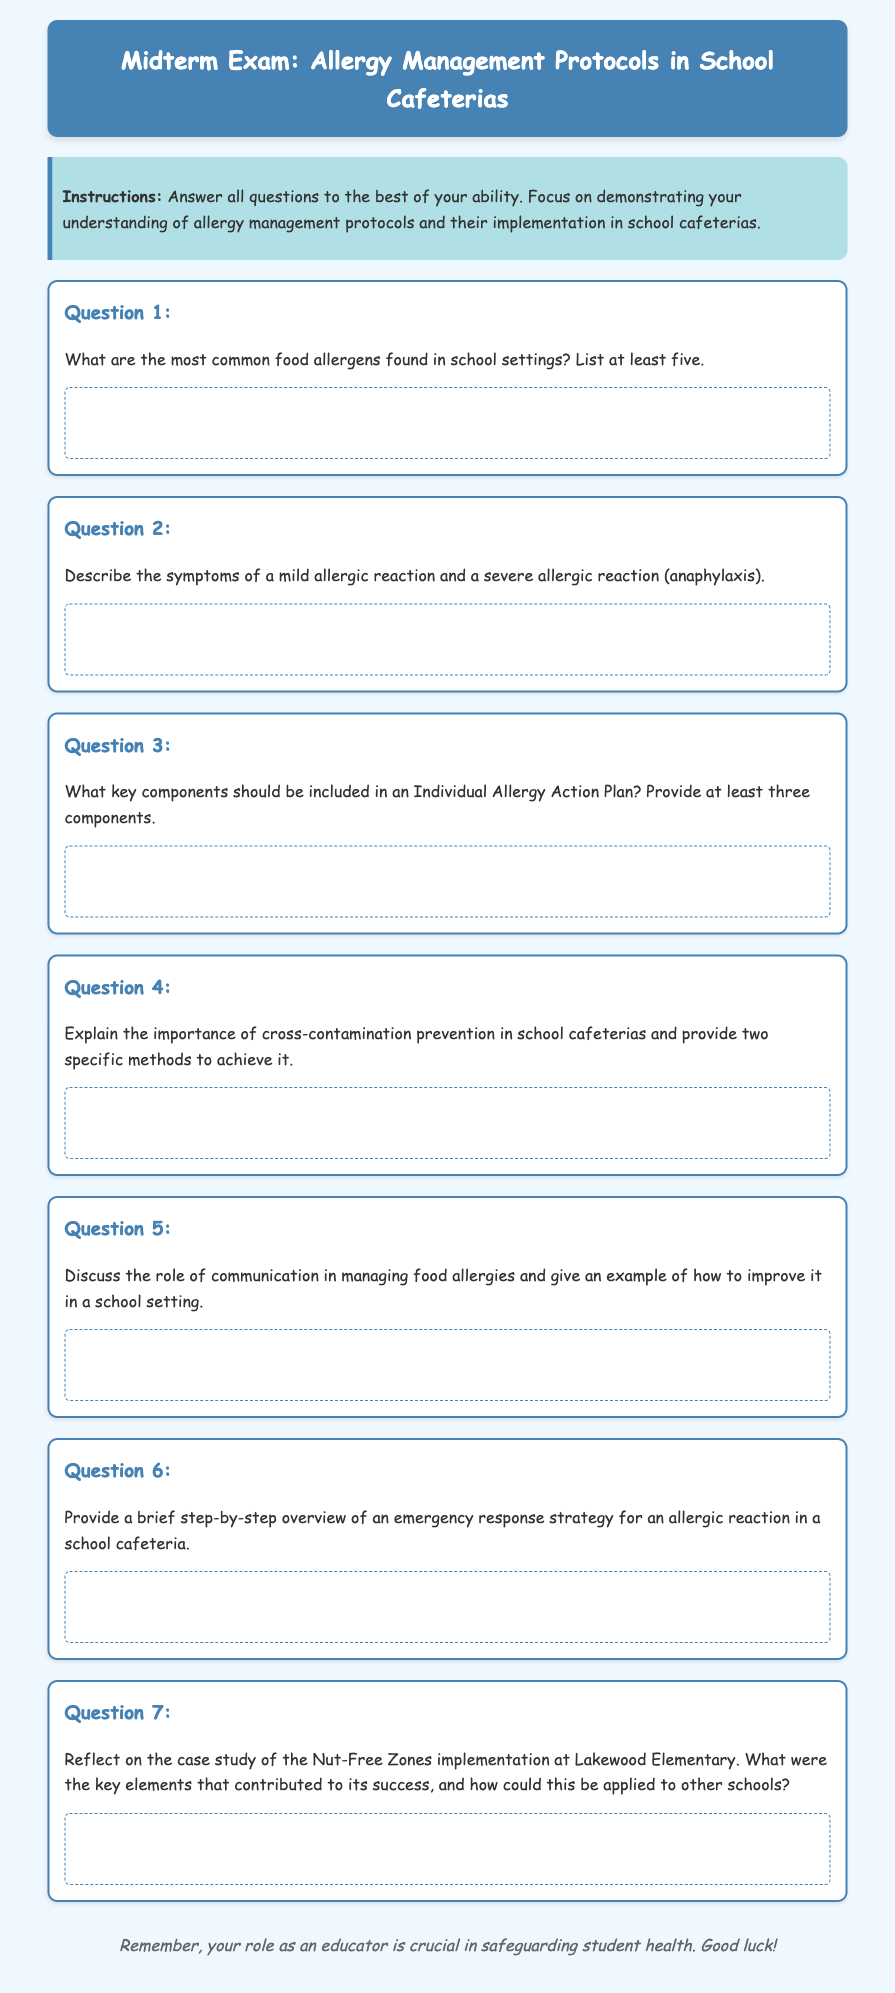What are the most common food allergens? The document requests a list of at least five common food allergens found in school settings.
Answer: Five What is an example of a severe allergic reaction? The document prompts for a description of a severe allergic reaction, namely anaphylaxis.
Answer: Anaphylaxis What are key components in an Individual Allergy Action Plan? The question highlights the need for at least three components that should be included in an Individual Allergy Action Plan.
Answer: Three components What is one method for preventing cross-contamination? The document emphasizes the importance of preventing cross-contamination in school cafeterias and requests two specific methods.
Answer: One method What is the role of communication in managing food allergies? The document seeks a discussion on the role of communication and examples of improving it in a school setting.
Answer: Communication What should be included in an emergency response strategy? The document requires a brief step-by-step overview of an emergency response strategy for an allergic reaction in a school cafeteria.
Answer: Overview What was implemented at Lakewood Elementary? The document refers to the specific implementation of Nut-Free Zones in a case study.
Answer: Nut-Free Zones What style is the document written in? The document utilizes a casual and friendly style, apparent from the choice of font and color scheme.
Answer: Casual style 